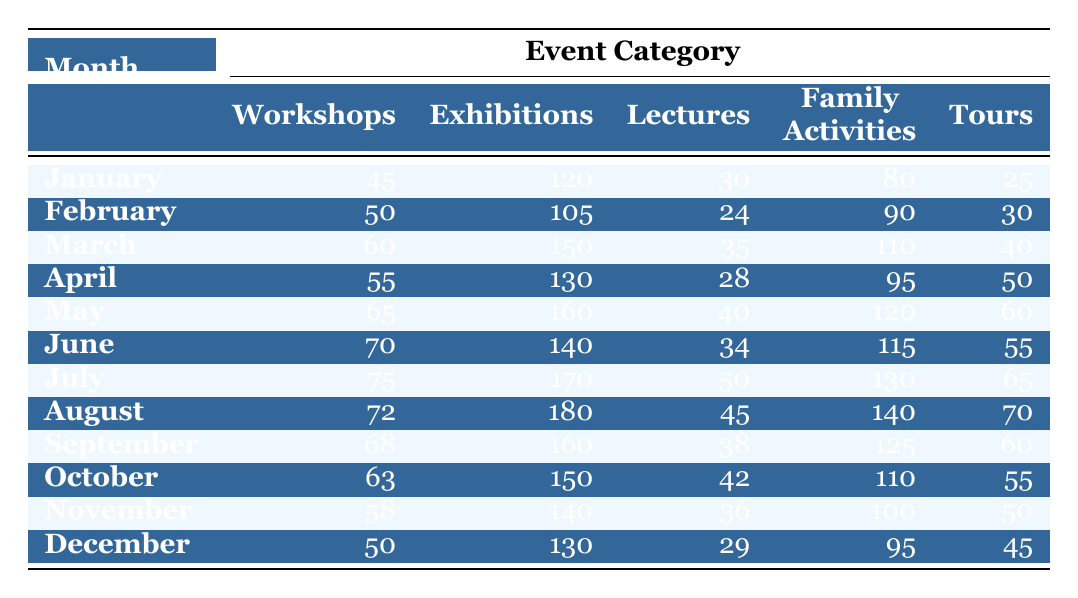What was the total attendance for Workshops in July? The table shows that in July, the attendance for Workshops was 75. Therefore, the total attendance for Workshops in July is 75.
Answer: 75 Which month had the highest attendance for Family Activities? Looking at the Family Activities column, August had the highest attendance with 140 participants.
Answer: August How many more attendees were at Exhibitions in May than in November? In May, the attendance for Exhibitions was 160, and in November, it was 140. The difference is 160 - 140 = 20.
Answer: 20 Is it true that there were more Lectures in March than in October? In March, the attendance for Lectures was 35, while in October it was 42. The statement is false.
Answer: No What is the average attendance for Tours across all months? Summing the Tours attendance gives: (25 + 30 + 40 + 50 + 60 + 55 + 65 + 70 + 60 + 55 + 50 + 45) =  615. There are 12 months, so the average is 615 / 12 = 51.25.
Answer: 51.25 In which month did the attendance for Workshops meet or exceed 60? The attendance for Workshops met or exceeded 60 starting from March (60), then April (55), May (65), June (70), July (75), August (72), September (68), October (63), November (58), and December (50). Therefore, the months are March, May, June, July, August, and September.
Answer: March, May, June, July, August, September Which event category had the lowest total attendance over the year? Summing the attendance in each event category: Workshops = 45 + 50 + 60 + 55 + 65 + 70 + 75 + 72 + 68 + 63 + 58 + 50 = 780, Exhibitions = 120 + 105 + 150 + 130 + 160 + 140 + 170 + 180 + 160 + 150 + 140 + 130 = 1715, Lectures = 30 + 24 + 35 + 28 + 40 + 34 + 50 + 45 + 38 + 42 + 36 + 29 = 489, Family Activities = 80 + 90 + 110 + 95 + 120 + 115 + 130 + 140 + 125 + 110 + 100 + 95 = 1415, Tours = 25 + 30 + 40 + 50 + 60 + 55 + 65 + 70 + 60 + 55 + 50 + 45 = 615. The lowest total is for Lectures, with 489.
Answer: Lectures 